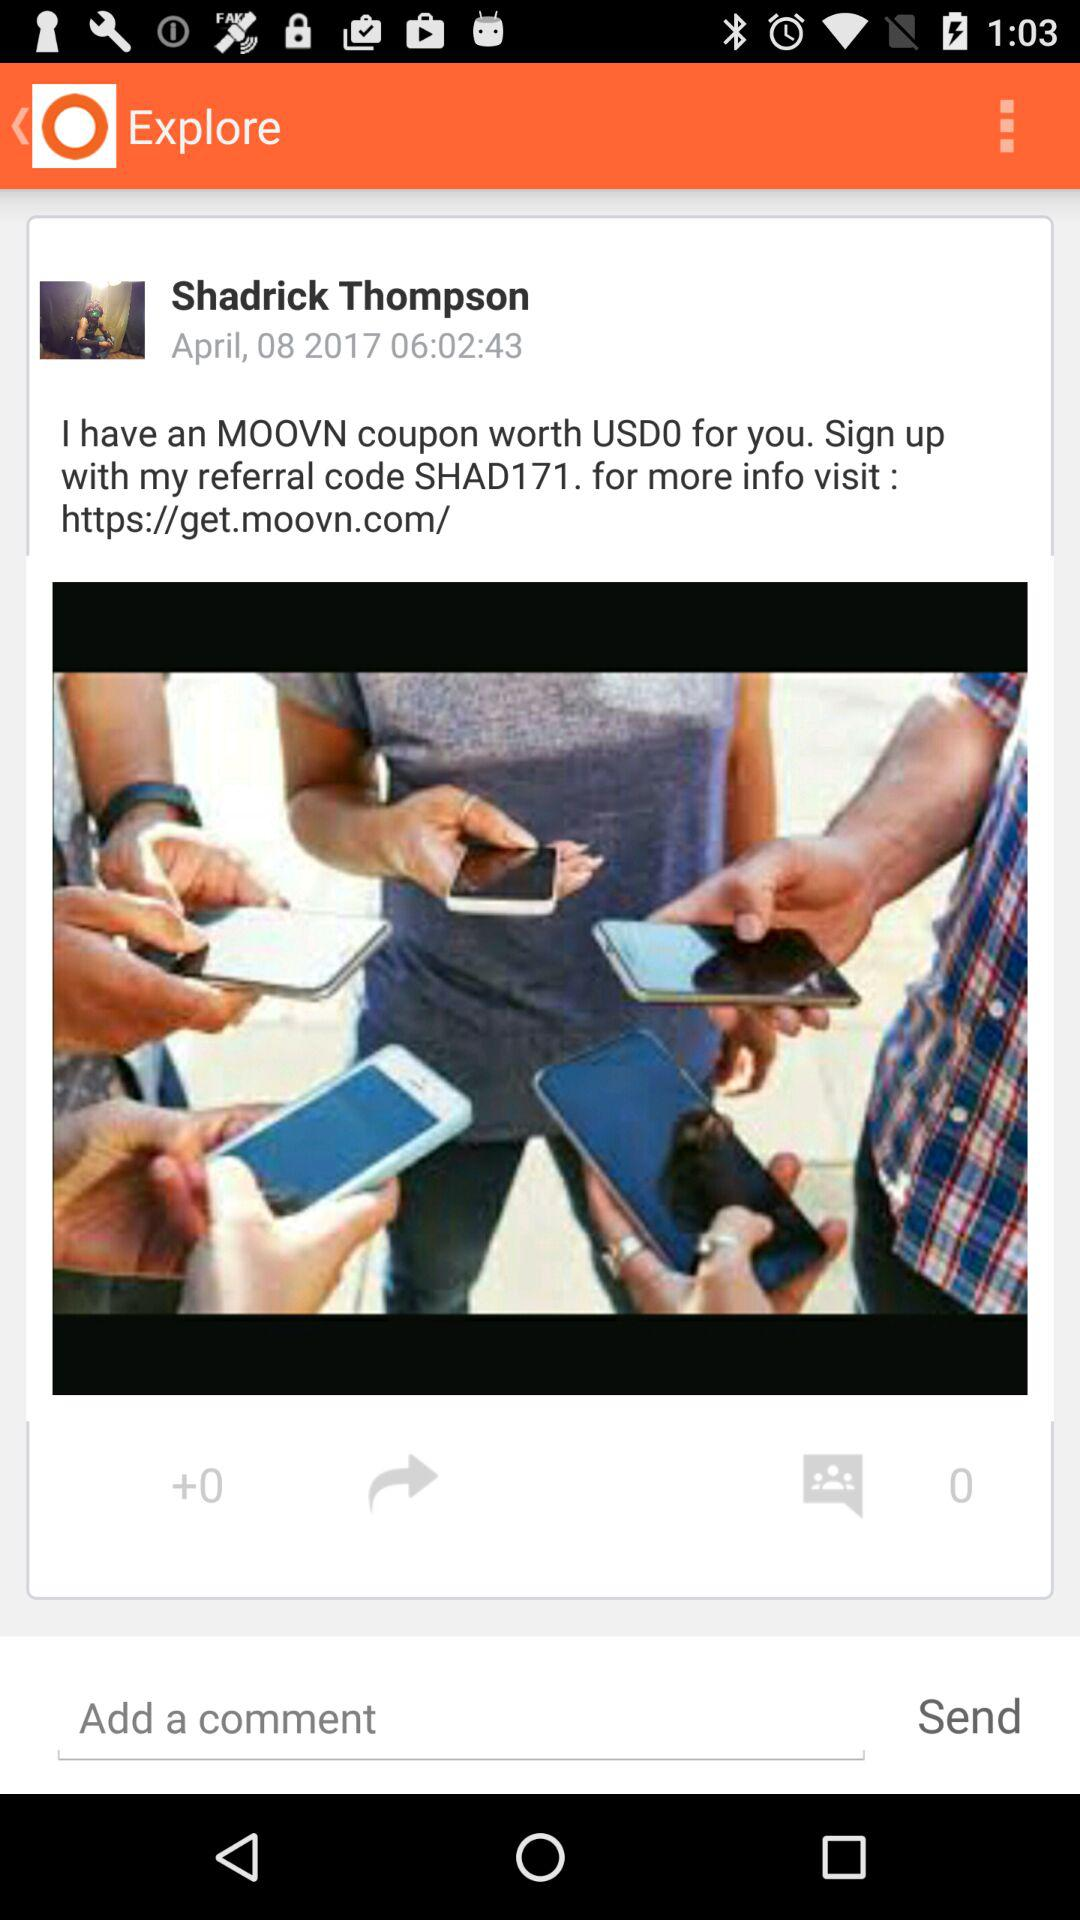What is the date? The date is April 8, 2017. 